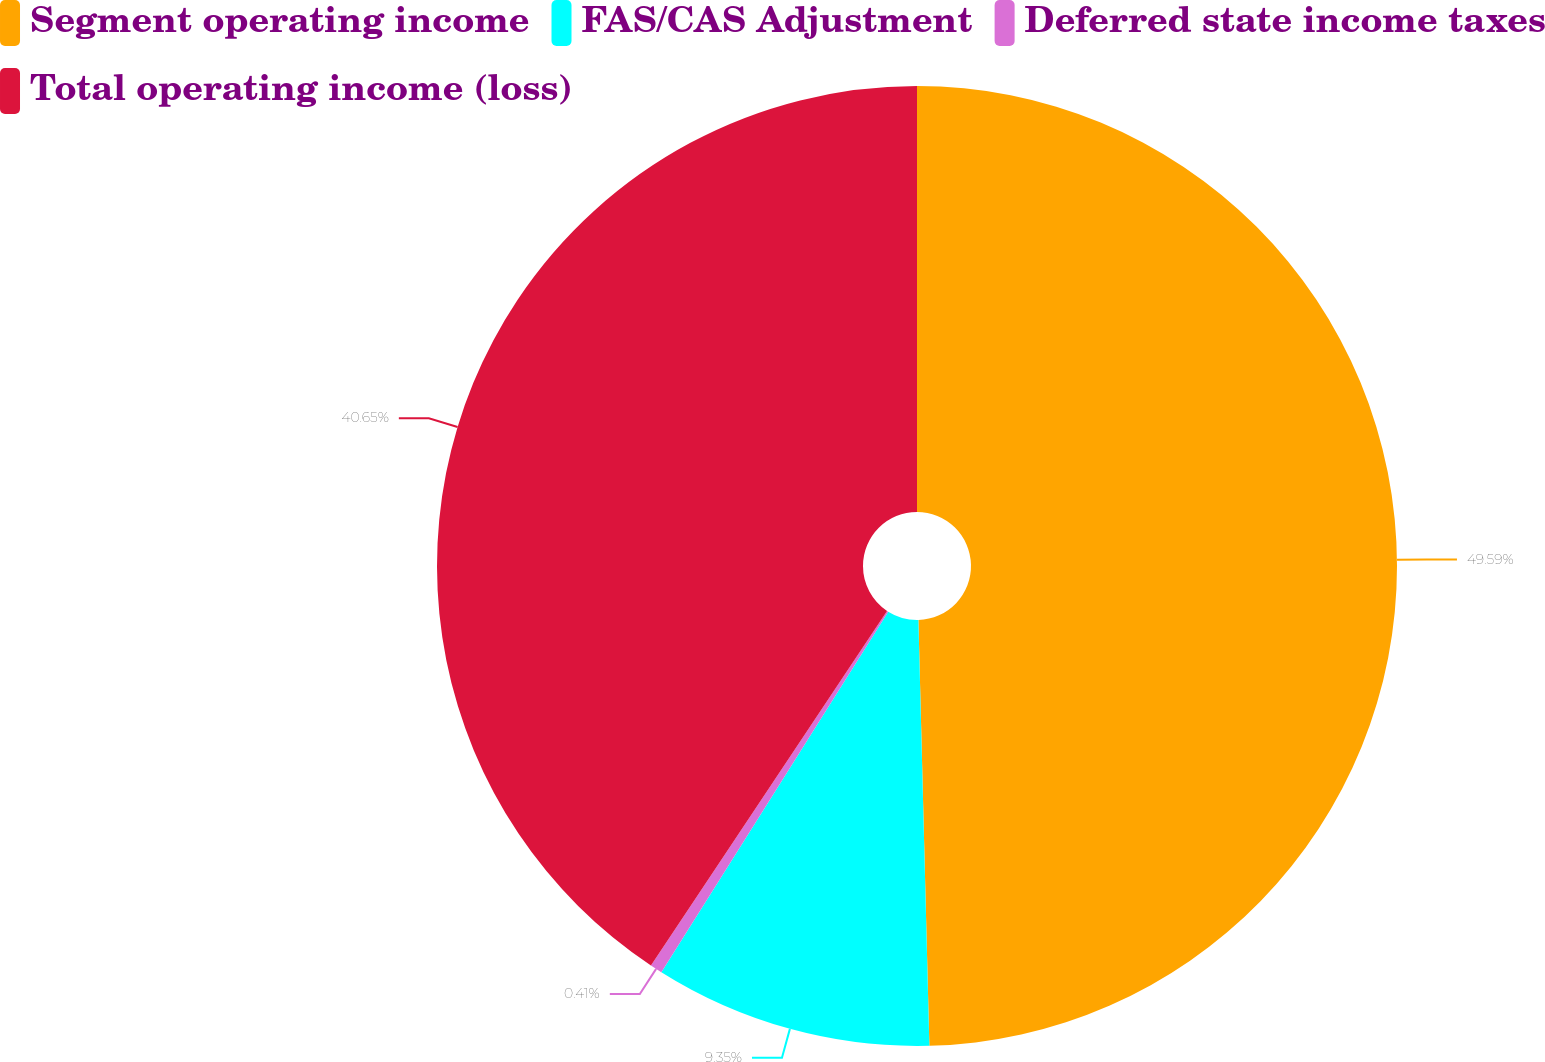Convert chart to OTSL. <chart><loc_0><loc_0><loc_500><loc_500><pie_chart><fcel>Segment operating income<fcel>FAS/CAS Adjustment<fcel>Deferred state income taxes<fcel>Total operating income (loss)<nl><fcel>49.59%<fcel>9.35%<fcel>0.41%<fcel>40.65%<nl></chart> 